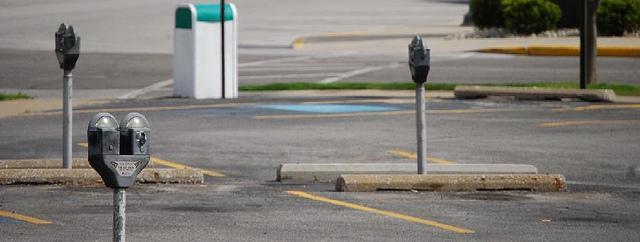How many parking meters do you see?
Give a very brief answer. 3. How many parking meters are there?
Give a very brief answer. 3. 